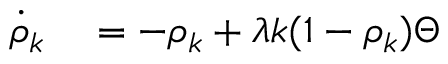<formula> <loc_0><loc_0><loc_500><loc_500>\begin{array} { r l } { \dot { \rho } _ { k } } & = - \rho _ { k } + \lambda k ( 1 - \rho _ { k } ) \Theta } \end{array}</formula> 